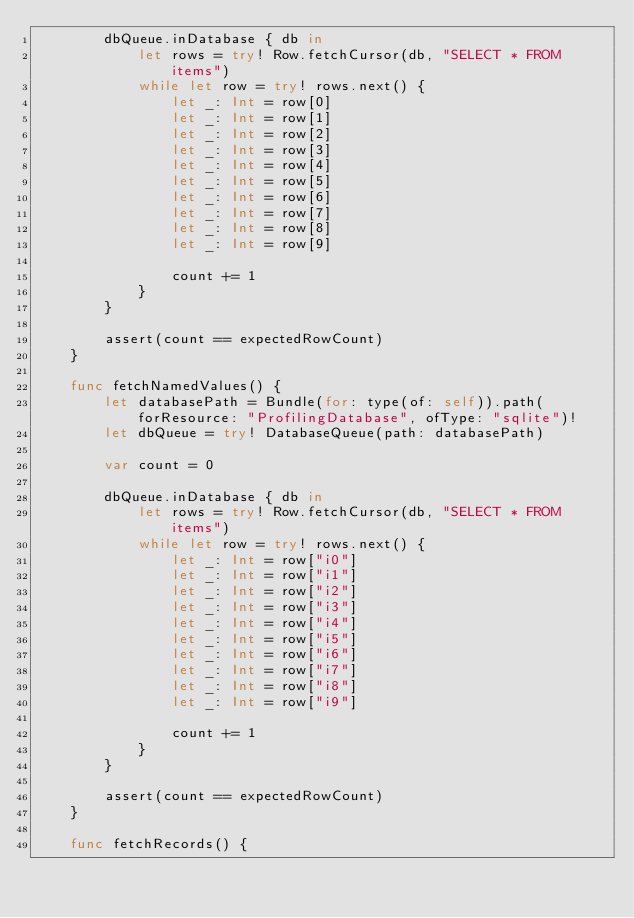Convert code to text. <code><loc_0><loc_0><loc_500><loc_500><_Swift_>        dbQueue.inDatabase { db in
            let rows = try! Row.fetchCursor(db, "SELECT * FROM items")
            while let row = try! rows.next() {
                let _: Int = row[0]
                let _: Int = row[1]
                let _: Int = row[2]
                let _: Int = row[3]
                let _: Int = row[4]
                let _: Int = row[5]
                let _: Int = row[6]
                let _: Int = row[7]
                let _: Int = row[8]
                let _: Int = row[9]
                
                count += 1
            }
        }
        
        assert(count == expectedRowCount)
    }
    
    func fetchNamedValues() {
        let databasePath = Bundle(for: type(of: self)).path(forResource: "ProfilingDatabase", ofType: "sqlite")!
        let dbQueue = try! DatabaseQueue(path: databasePath)
        
        var count = 0
        
        dbQueue.inDatabase { db in
            let rows = try! Row.fetchCursor(db, "SELECT * FROM items")
            while let row = try! rows.next() {
                let _: Int = row["i0"]
                let _: Int = row["i1"]
                let _: Int = row["i2"]
                let _: Int = row["i3"]
                let _: Int = row["i4"]
                let _: Int = row["i5"]
                let _: Int = row["i6"]
                let _: Int = row["i7"]
                let _: Int = row["i8"]
                let _: Int = row["i9"]
                
                count += 1
            }
        }
        
        assert(count == expectedRowCount)
    }
    
    func fetchRecords() {</code> 